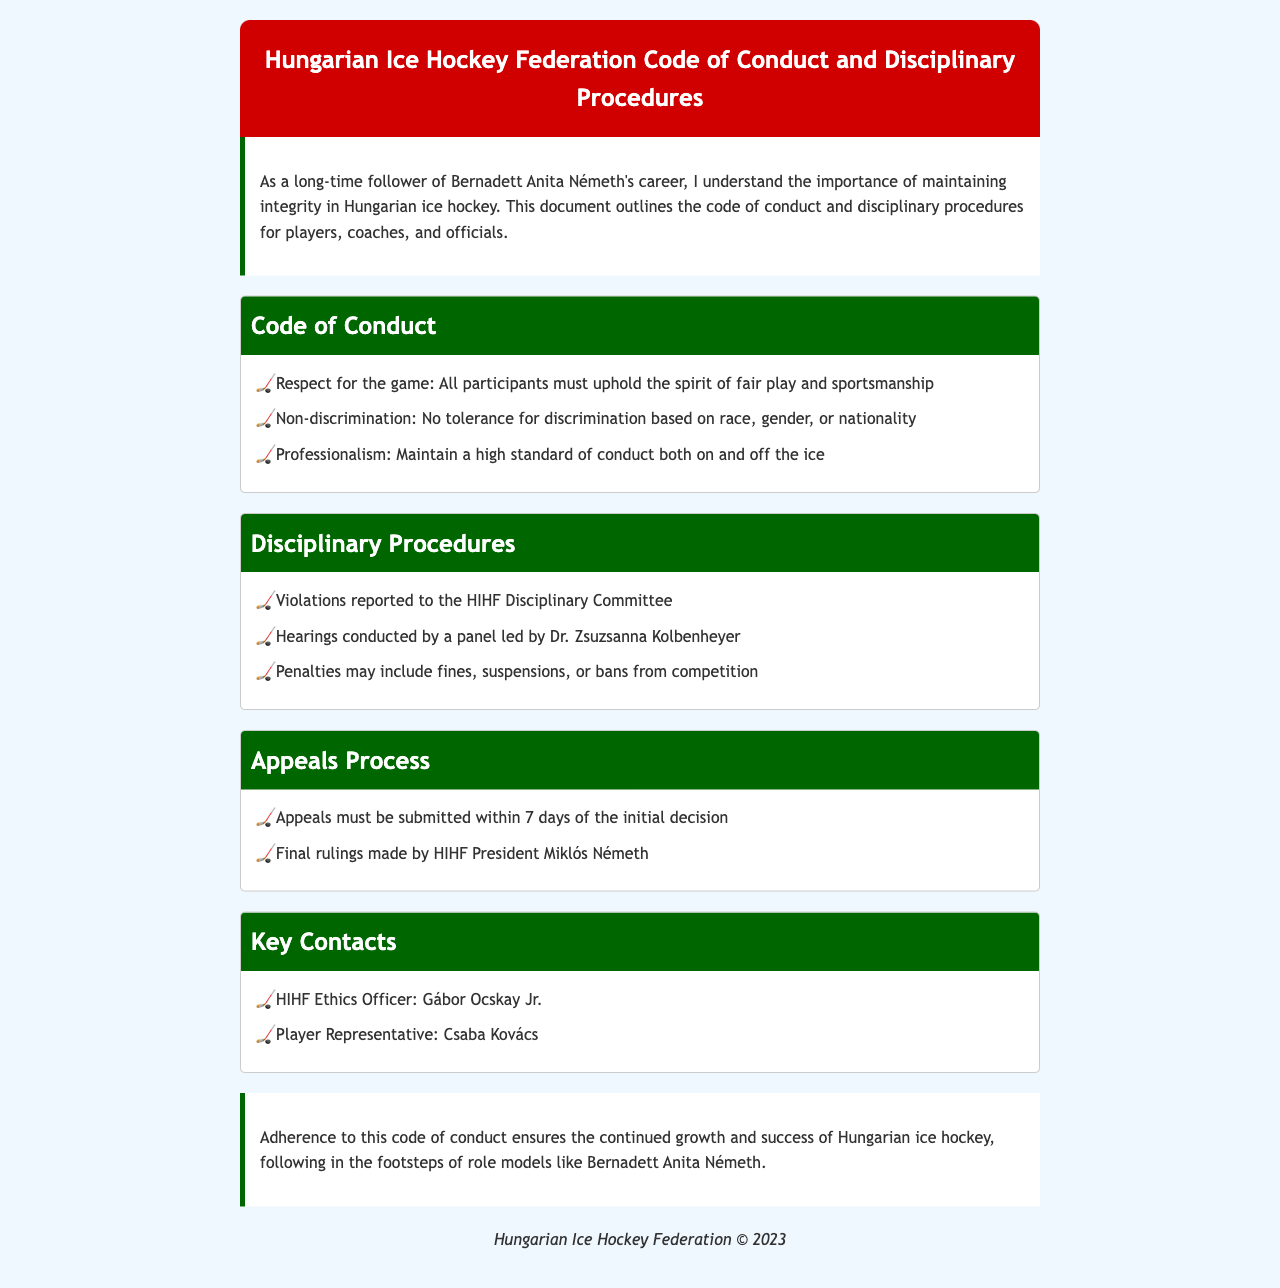What is the title of the document? The title is provided in the header section of the document, stating the subject matter explicitly.
Answer: Hungarian Ice Hockey Federation Code of Conduct and Disciplinary Procedures Who leads the hearings in the disciplinary procedures? The document specifies that a panel led by a specific individual is responsible for conducting hearings.
Answer: Dr. Zsuzsanna Kolbenheyer Name one of the key contacts listed. The document highlights specific individuals that hold important positions within the federation, providing their names as key contacts.
Answer: Gábor Ocskay Jr What must be submitted within 7 days according to the appeals process? The document mentions a specific action that must be taken within a defined timeframe in the appeals process section.
Answer: Appeals What is one of the standards players must maintain? The document outlines the expected standards of conduct for players, coaches, and officials, emphasizing professionalism.
Answer: Professionalism What is the penalty for violations mentioned? The document details the consequences for misconduct, including specific penalties that may be imposed.
Answer: Fines Is discrimination tolerated in Hungarian ice hockey? The document clearly states the federation's stance on discrimination within the sport.
Answer: No Who is the player representative listed? The document includes a designated representative for players, identifying them by name.
Answer: Csaba Kovács 